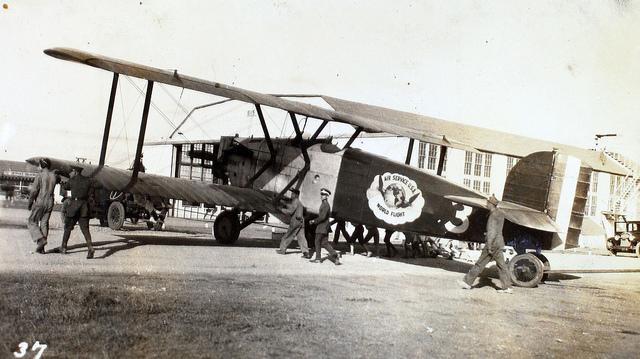What vehicle is being shown?
Be succinct. Airplane. What number is in the bottom left corner?
Keep it brief. 37. What makes the plane go?
Keep it brief. Engine. 